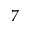Convert formula to latex. <formula><loc_0><loc_0><loc_500><loc_500>7</formula> 